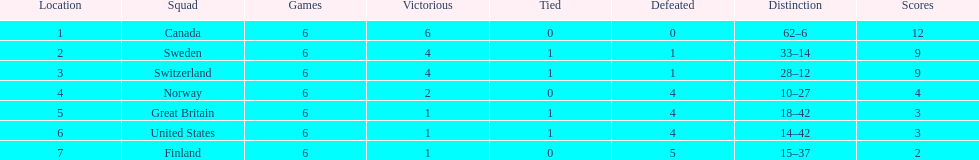Which team won more matches, finland or norway? Norway. 